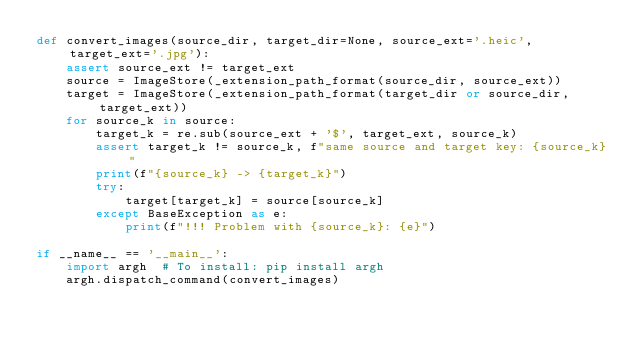Convert code to text. <code><loc_0><loc_0><loc_500><loc_500><_Python_>def convert_images(source_dir, target_dir=None, source_ext='.heic', target_ext='.jpg'):
    assert source_ext != target_ext
    source = ImageStore(_extension_path_format(source_dir, source_ext))
    target = ImageStore(_extension_path_format(target_dir or source_dir, target_ext))
    for source_k in source:
        target_k = re.sub(source_ext + '$', target_ext, source_k)
        assert target_k != source_k, f"same source and target key: {source_k}"
        print(f"{source_k} -> {target_k}")
        try:
            target[target_k] = source[source_k]
        except BaseException as e:
            print(f"!!! Problem with {source_k}: {e}")

if __name__ == '__main__':
    import argh  # To install: pip install argh
    argh.dispatch_command(convert_images)</code> 